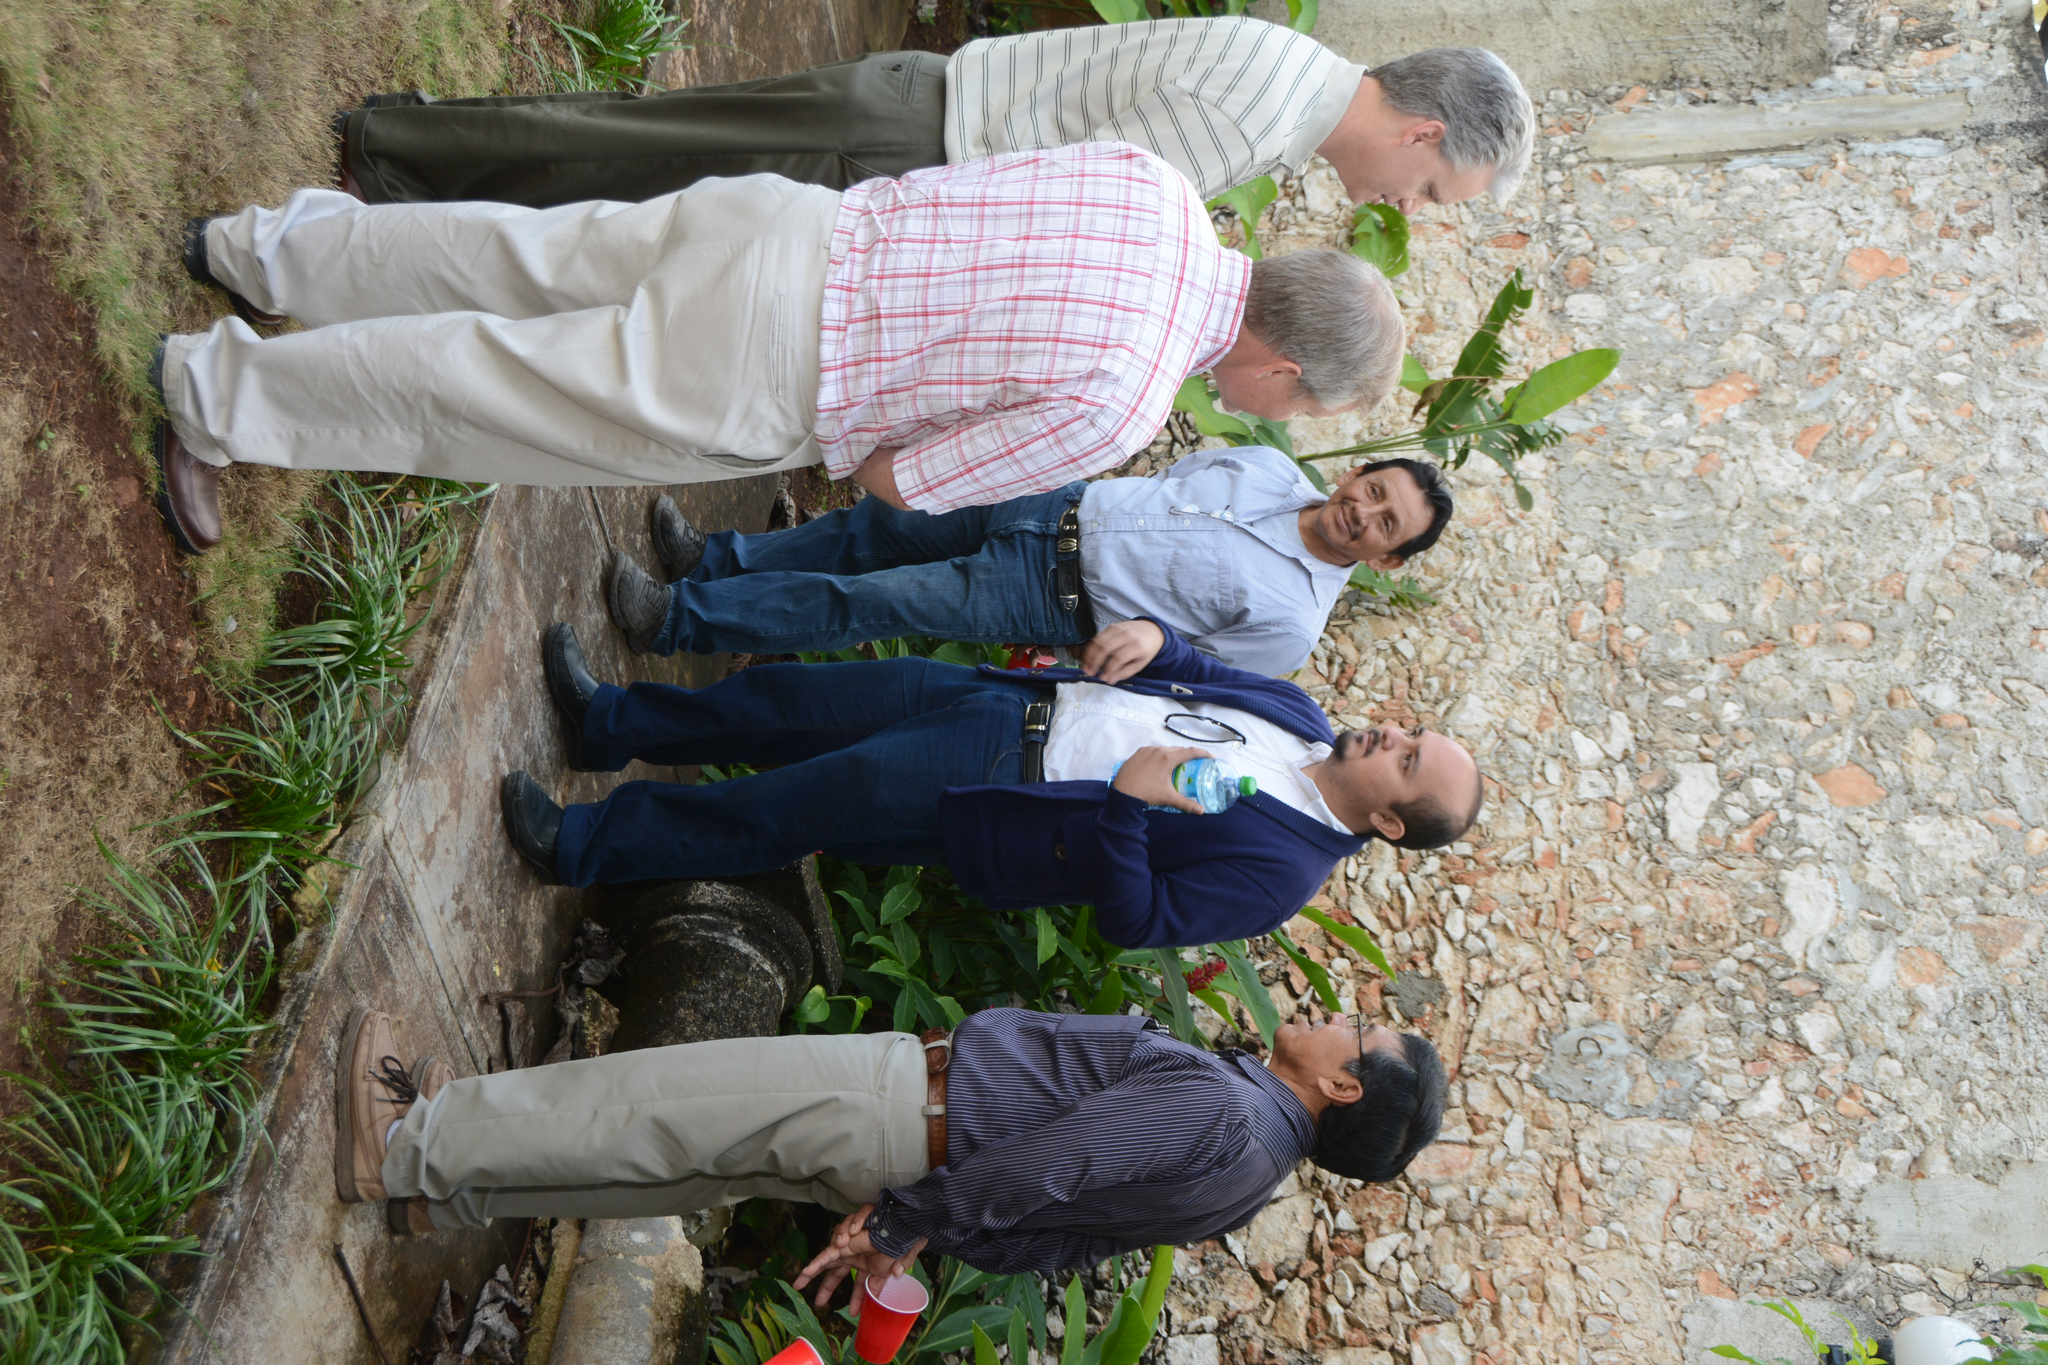Describe this image in one or two sentences. In the center of the image we can see a few people are standing and they are in different costumes. Among them, we can see two persons are holding some objects and one person is smiling. In the background there is a wall, plants, grass and a few other objects. 